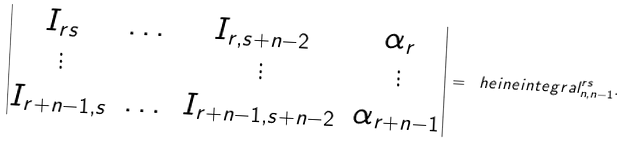Convert formula to latex. <formula><loc_0><loc_0><loc_500><loc_500>\begin{vmatrix} I _ { r s } & \dots & I _ { r , s + n - 2 } & \alpha _ { r } \\ \vdots & & \vdots & \vdots \\ I _ { r + n - 1 , s } & \dots & I _ { r + n - 1 , s + n - 2 } & \alpha _ { r + n - 1 } \\ \end{vmatrix} = \ h e i n e i n t e g r a l _ { n , n - 1 } ^ { r s } .</formula> 